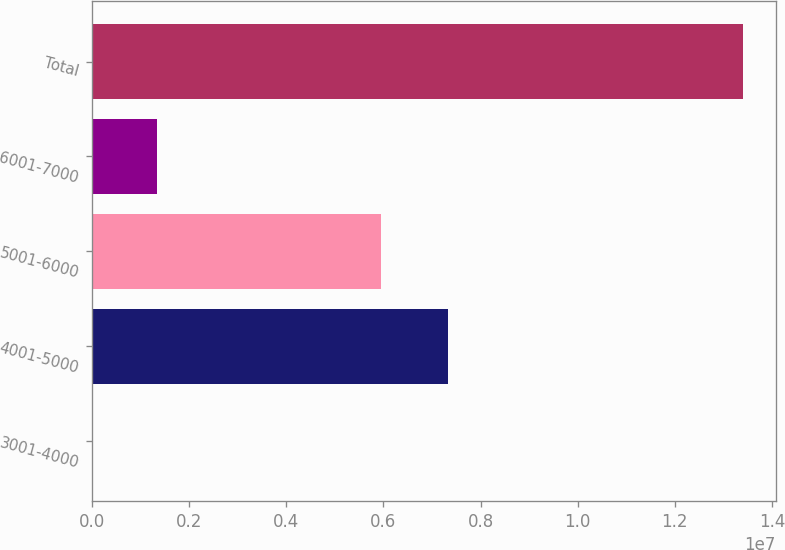Convert chart. <chart><loc_0><loc_0><loc_500><loc_500><bar_chart><fcel>3001-4000<fcel>4001-5000<fcel>5001-6000<fcel>6001-7000<fcel>Total<nl><fcel>250<fcel>7.32426e+06<fcel>5.95718e+06<fcel>1.34081e+06<fcel>1.34059e+07<nl></chart> 